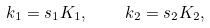<formula> <loc_0><loc_0><loc_500><loc_500>k _ { 1 } = s _ { 1 } K _ { 1 } , \quad k _ { 2 } = s _ { 2 } K _ { 2 } ,</formula> 